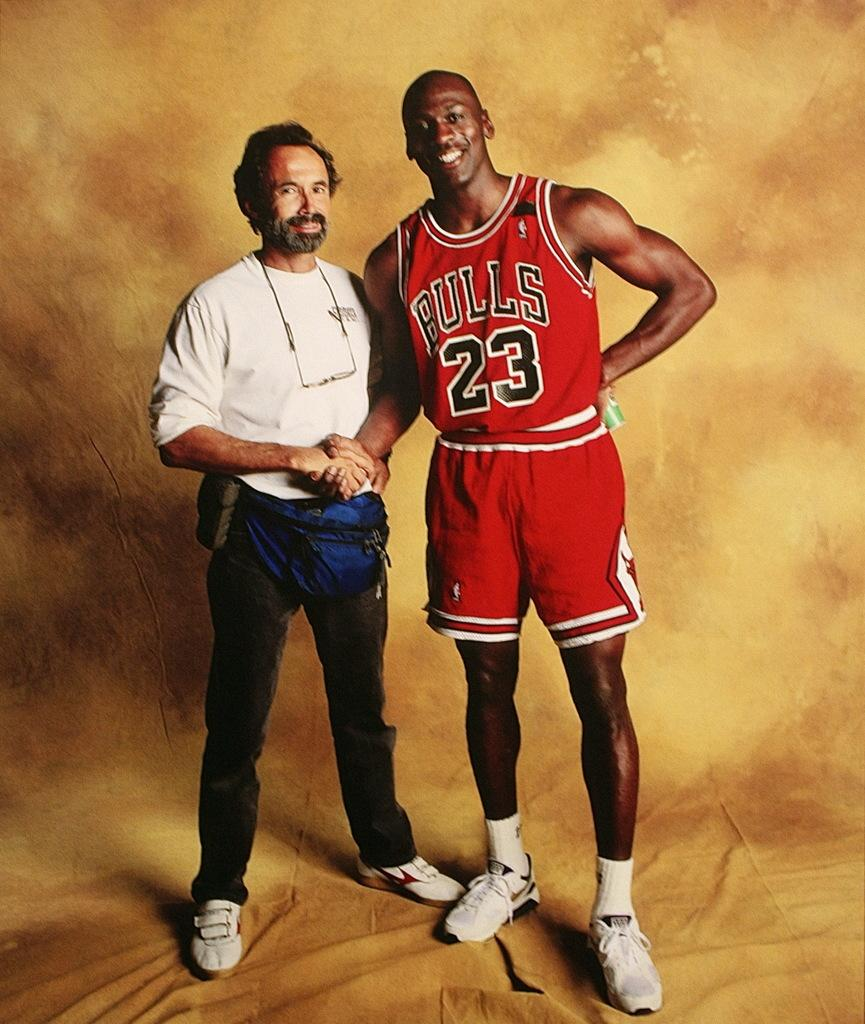<image>
Relay a brief, clear account of the picture shown. Michael Jordan wears a Bulls jersey and shakes someone's hand. 